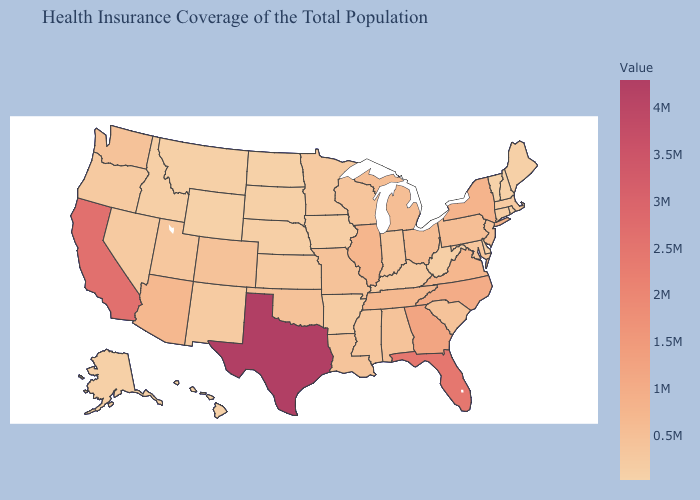Is the legend a continuous bar?
Be succinct. Yes. Which states have the highest value in the USA?
Quick response, please. Texas. Which states hav the highest value in the Northeast?
Write a very short answer. New York. 